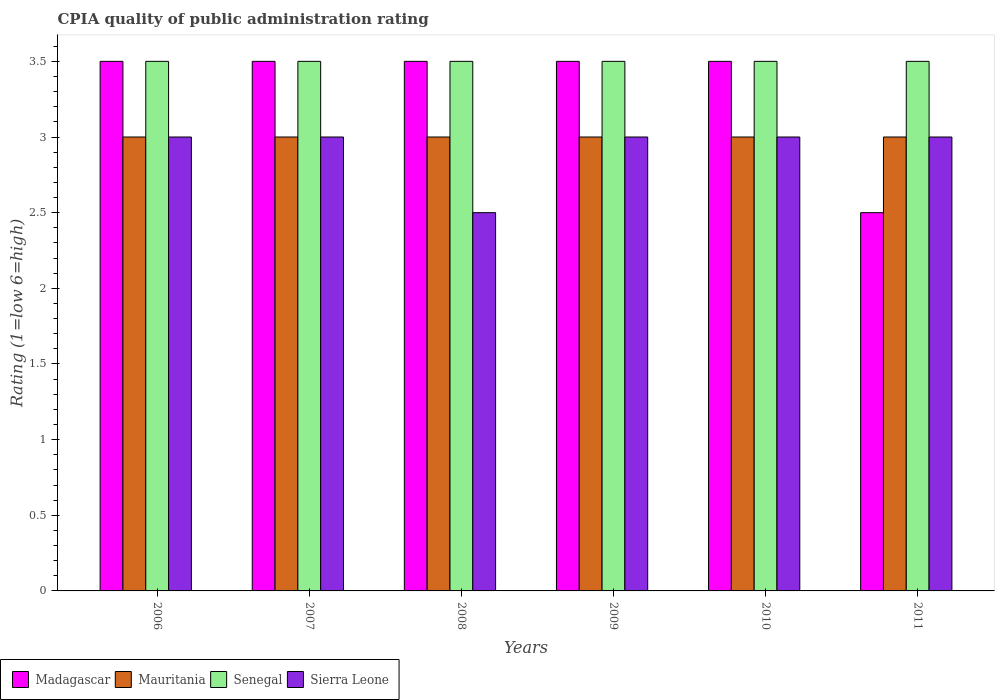How many different coloured bars are there?
Your response must be concise. 4. Are the number of bars on each tick of the X-axis equal?
Provide a short and direct response. Yes. In how many cases, is the number of bars for a given year not equal to the number of legend labels?
Your response must be concise. 0. In which year was the CPIA rating in Senegal maximum?
Your response must be concise. 2006. What is the difference between the CPIA rating in Madagascar in 2007 and that in 2008?
Ensure brevity in your answer.  0. What is the average CPIA rating in Sierra Leone per year?
Ensure brevity in your answer.  2.92. In the year 2006, what is the difference between the CPIA rating in Madagascar and CPIA rating in Sierra Leone?
Provide a succinct answer. 0.5. What is the ratio of the CPIA rating in Mauritania in 2007 to that in 2011?
Your answer should be very brief. 1. Is the CPIA rating in Sierra Leone in 2010 less than that in 2011?
Your response must be concise. No. Is the difference between the CPIA rating in Madagascar in 2010 and 2011 greater than the difference between the CPIA rating in Sierra Leone in 2010 and 2011?
Provide a short and direct response. Yes. What is the difference between the highest and the second highest CPIA rating in Madagascar?
Provide a succinct answer. 0. What is the difference between the highest and the lowest CPIA rating in Senegal?
Your answer should be compact. 0. Is it the case that in every year, the sum of the CPIA rating in Sierra Leone and CPIA rating in Mauritania is greater than the sum of CPIA rating in Madagascar and CPIA rating in Senegal?
Ensure brevity in your answer.  No. What does the 4th bar from the left in 2009 represents?
Provide a short and direct response. Sierra Leone. What does the 4th bar from the right in 2006 represents?
Offer a very short reply. Madagascar. How many years are there in the graph?
Keep it short and to the point. 6. Are the values on the major ticks of Y-axis written in scientific E-notation?
Offer a very short reply. No. Where does the legend appear in the graph?
Provide a succinct answer. Bottom left. How many legend labels are there?
Your answer should be compact. 4. What is the title of the graph?
Offer a very short reply. CPIA quality of public administration rating. Does "Europe(developing only)" appear as one of the legend labels in the graph?
Make the answer very short. No. What is the label or title of the X-axis?
Your response must be concise. Years. What is the Rating (1=low 6=high) in Mauritania in 2006?
Your answer should be very brief. 3. What is the Rating (1=low 6=high) in Senegal in 2006?
Your answer should be very brief. 3.5. What is the Rating (1=low 6=high) in Madagascar in 2007?
Ensure brevity in your answer.  3.5. What is the Rating (1=low 6=high) of Mauritania in 2007?
Your response must be concise. 3. What is the Rating (1=low 6=high) in Senegal in 2007?
Provide a succinct answer. 3.5. What is the Rating (1=low 6=high) in Sierra Leone in 2007?
Offer a very short reply. 3. What is the Rating (1=low 6=high) in Madagascar in 2008?
Your answer should be compact. 3.5. What is the Rating (1=low 6=high) in Sierra Leone in 2008?
Your answer should be very brief. 2.5. What is the Rating (1=low 6=high) of Madagascar in 2009?
Your answer should be very brief. 3.5. What is the Rating (1=low 6=high) of Senegal in 2009?
Keep it short and to the point. 3.5. What is the Rating (1=low 6=high) of Madagascar in 2010?
Provide a succinct answer. 3.5. What is the Rating (1=low 6=high) of Senegal in 2010?
Your answer should be compact. 3.5. What is the Rating (1=low 6=high) in Sierra Leone in 2010?
Provide a succinct answer. 3. What is the Rating (1=low 6=high) in Madagascar in 2011?
Give a very brief answer. 2.5. What is the Rating (1=low 6=high) in Senegal in 2011?
Your response must be concise. 3.5. Across all years, what is the maximum Rating (1=low 6=high) of Madagascar?
Offer a very short reply. 3.5. Across all years, what is the maximum Rating (1=low 6=high) in Mauritania?
Give a very brief answer. 3. Across all years, what is the minimum Rating (1=low 6=high) in Madagascar?
Offer a terse response. 2.5. Across all years, what is the minimum Rating (1=low 6=high) of Sierra Leone?
Offer a terse response. 2.5. What is the total Rating (1=low 6=high) in Madagascar in the graph?
Offer a terse response. 20. What is the total Rating (1=low 6=high) in Mauritania in the graph?
Offer a terse response. 18. What is the total Rating (1=low 6=high) in Senegal in the graph?
Provide a short and direct response. 21. What is the difference between the Rating (1=low 6=high) in Madagascar in 2006 and that in 2007?
Your response must be concise. 0. What is the difference between the Rating (1=low 6=high) in Mauritania in 2006 and that in 2007?
Offer a very short reply. 0. What is the difference between the Rating (1=low 6=high) in Senegal in 2006 and that in 2007?
Ensure brevity in your answer.  0. What is the difference between the Rating (1=low 6=high) in Mauritania in 2006 and that in 2008?
Offer a very short reply. 0. What is the difference between the Rating (1=low 6=high) of Mauritania in 2006 and that in 2009?
Your response must be concise. 0. What is the difference between the Rating (1=low 6=high) of Senegal in 2006 and that in 2009?
Provide a short and direct response. 0. What is the difference between the Rating (1=low 6=high) of Sierra Leone in 2006 and that in 2009?
Offer a terse response. 0. What is the difference between the Rating (1=low 6=high) in Madagascar in 2006 and that in 2010?
Offer a terse response. 0. What is the difference between the Rating (1=low 6=high) in Senegal in 2006 and that in 2010?
Offer a terse response. 0. What is the difference between the Rating (1=low 6=high) of Madagascar in 2006 and that in 2011?
Offer a terse response. 1. What is the difference between the Rating (1=low 6=high) in Mauritania in 2006 and that in 2011?
Provide a succinct answer. 0. What is the difference between the Rating (1=low 6=high) of Senegal in 2006 and that in 2011?
Provide a short and direct response. 0. What is the difference between the Rating (1=low 6=high) in Madagascar in 2007 and that in 2009?
Offer a very short reply. 0. What is the difference between the Rating (1=low 6=high) of Sierra Leone in 2007 and that in 2009?
Provide a short and direct response. 0. What is the difference between the Rating (1=low 6=high) in Madagascar in 2007 and that in 2011?
Give a very brief answer. 1. What is the difference between the Rating (1=low 6=high) in Mauritania in 2007 and that in 2011?
Your answer should be compact. 0. What is the difference between the Rating (1=low 6=high) in Sierra Leone in 2008 and that in 2009?
Make the answer very short. -0.5. What is the difference between the Rating (1=low 6=high) of Mauritania in 2008 and that in 2011?
Make the answer very short. 0. What is the difference between the Rating (1=low 6=high) in Madagascar in 2009 and that in 2010?
Give a very brief answer. 0. What is the difference between the Rating (1=low 6=high) of Senegal in 2009 and that in 2010?
Your answer should be compact. 0. What is the difference between the Rating (1=low 6=high) in Madagascar in 2009 and that in 2011?
Provide a short and direct response. 1. What is the difference between the Rating (1=low 6=high) in Mauritania in 2009 and that in 2011?
Your answer should be very brief. 0. What is the difference between the Rating (1=low 6=high) of Senegal in 2009 and that in 2011?
Provide a short and direct response. 0. What is the difference between the Rating (1=low 6=high) in Sierra Leone in 2009 and that in 2011?
Offer a very short reply. 0. What is the difference between the Rating (1=low 6=high) in Madagascar in 2010 and that in 2011?
Offer a very short reply. 1. What is the difference between the Rating (1=low 6=high) of Senegal in 2010 and that in 2011?
Your answer should be compact. 0. What is the difference between the Rating (1=low 6=high) in Mauritania in 2006 and the Rating (1=low 6=high) in Senegal in 2007?
Provide a short and direct response. -0.5. What is the difference between the Rating (1=low 6=high) in Mauritania in 2006 and the Rating (1=low 6=high) in Sierra Leone in 2007?
Keep it short and to the point. 0. What is the difference between the Rating (1=low 6=high) of Senegal in 2006 and the Rating (1=low 6=high) of Sierra Leone in 2007?
Your answer should be compact. 0.5. What is the difference between the Rating (1=low 6=high) in Madagascar in 2006 and the Rating (1=low 6=high) in Mauritania in 2008?
Your answer should be compact. 0.5. What is the difference between the Rating (1=low 6=high) of Madagascar in 2006 and the Rating (1=low 6=high) of Senegal in 2008?
Your answer should be compact. 0. What is the difference between the Rating (1=low 6=high) of Mauritania in 2006 and the Rating (1=low 6=high) of Sierra Leone in 2008?
Make the answer very short. 0.5. What is the difference between the Rating (1=low 6=high) in Madagascar in 2006 and the Rating (1=low 6=high) in Mauritania in 2009?
Provide a succinct answer. 0.5. What is the difference between the Rating (1=low 6=high) in Madagascar in 2006 and the Rating (1=low 6=high) in Senegal in 2009?
Keep it short and to the point. 0. What is the difference between the Rating (1=low 6=high) in Madagascar in 2006 and the Rating (1=low 6=high) in Sierra Leone in 2009?
Keep it short and to the point. 0.5. What is the difference between the Rating (1=low 6=high) in Mauritania in 2006 and the Rating (1=low 6=high) in Senegal in 2009?
Ensure brevity in your answer.  -0.5. What is the difference between the Rating (1=low 6=high) in Mauritania in 2006 and the Rating (1=low 6=high) in Sierra Leone in 2009?
Provide a succinct answer. 0. What is the difference between the Rating (1=low 6=high) of Madagascar in 2006 and the Rating (1=low 6=high) of Mauritania in 2010?
Offer a very short reply. 0.5. What is the difference between the Rating (1=low 6=high) in Madagascar in 2006 and the Rating (1=low 6=high) in Sierra Leone in 2010?
Keep it short and to the point. 0.5. What is the difference between the Rating (1=low 6=high) of Mauritania in 2006 and the Rating (1=low 6=high) of Senegal in 2010?
Your answer should be very brief. -0.5. What is the difference between the Rating (1=low 6=high) in Senegal in 2006 and the Rating (1=low 6=high) in Sierra Leone in 2010?
Your answer should be compact. 0.5. What is the difference between the Rating (1=low 6=high) of Madagascar in 2006 and the Rating (1=low 6=high) of Mauritania in 2011?
Your answer should be very brief. 0.5. What is the difference between the Rating (1=low 6=high) in Mauritania in 2006 and the Rating (1=low 6=high) in Senegal in 2011?
Make the answer very short. -0.5. What is the difference between the Rating (1=low 6=high) in Senegal in 2006 and the Rating (1=low 6=high) in Sierra Leone in 2011?
Ensure brevity in your answer.  0.5. What is the difference between the Rating (1=low 6=high) in Madagascar in 2007 and the Rating (1=low 6=high) in Mauritania in 2008?
Provide a short and direct response. 0.5. What is the difference between the Rating (1=low 6=high) of Madagascar in 2007 and the Rating (1=low 6=high) of Senegal in 2008?
Offer a very short reply. 0. What is the difference between the Rating (1=low 6=high) of Madagascar in 2007 and the Rating (1=low 6=high) of Sierra Leone in 2008?
Provide a succinct answer. 1. What is the difference between the Rating (1=low 6=high) of Mauritania in 2007 and the Rating (1=low 6=high) of Senegal in 2008?
Your answer should be compact. -0.5. What is the difference between the Rating (1=low 6=high) of Mauritania in 2007 and the Rating (1=low 6=high) of Sierra Leone in 2008?
Provide a succinct answer. 0.5. What is the difference between the Rating (1=low 6=high) in Senegal in 2007 and the Rating (1=low 6=high) in Sierra Leone in 2008?
Your answer should be very brief. 1. What is the difference between the Rating (1=low 6=high) of Madagascar in 2007 and the Rating (1=low 6=high) of Senegal in 2009?
Provide a short and direct response. 0. What is the difference between the Rating (1=low 6=high) of Mauritania in 2007 and the Rating (1=low 6=high) of Senegal in 2009?
Make the answer very short. -0.5. What is the difference between the Rating (1=low 6=high) of Madagascar in 2007 and the Rating (1=low 6=high) of Senegal in 2010?
Provide a succinct answer. 0. What is the difference between the Rating (1=low 6=high) in Mauritania in 2007 and the Rating (1=low 6=high) in Senegal in 2010?
Provide a short and direct response. -0.5. What is the difference between the Rating (1=low 6=high) in Madagascar in 2007 and the Rating (1=low 6=high) in Mauritania in 2011?
Your answer should be compact. 0.5. What is the difference between the Rating (1=low 6=high) of Madagascar in 2007 and the Rating (1=low 6=high) of Sierra Leone in 2011?
Make the answer very short. 0.5. What is the difference between the Rating (1=low 6=high) in Mauritania in 2007 and the Rating (1=low 6=high) in Senegal in 2011?
Provide a succinct answer. -0.5. What is the difference between the Rating (1=low 6=high) of Mauritania in 2007 and the Rating (1=low 6=high) of Sierra Leone in 2011?
Ensure brevity in your answer.  0. What is the difference between the Rating (1=low 6=high) in Madagascar in 2008 and the Rating (1=low 6=high) in Senegal in 2009?
Your response must be concise. 0. What is the difference between the Rating (1=low 6=high) in Madagascar in 2008 and the Rating (1=low 6=high) in Sierra Leone in 2009?
Make the answer very short. 0.5. What is the difference between the Rating (1=low 6=high) of Senegal in 2008 and the Rating (1=low 6=high) of Sierra Leone in 2009?
Make the answer very short. 0.5. What is the difference between the Rating (1=low 6=high) of Madagascar in 2008 and the Rating (1=low 6=high) of Senegal in 2010?
Your answer should be very brief. 0. What is the difference between the Rating (1=low 6=high) in Mauritania in 2008 and the Rating (1=low 6=high) in Senegal in 2010?
Ensure brevity in your answer.  -0.5. What is the difference between the Rating (1=low 6=high) of Mauritania in 2008 and the Rating (1=low 6=high) of Sierra Leone in 2010?
Give a very brief answer. 0. What is the difference between the Rating (1=low 6=high) in Madagascar in 2008 and the Rating (1=low 6=high) in Mauritania in 2011?
Offer a terse response. 0.5. What is the difference between the Rating (1=low 6=high) of Madagascar in 2008 and the Rating (1=low 6=high) of Senegal in 2011?
Provide a succinct answer. 0. What is the difference between the Rating (1=low 6=high) of Madagascar in 2008 and the Rating (1=low 6=high) of Sierra Leone in 2011?
Keep it short and to the point. 0.5. What is the difference between the Rating (1=low 6=high) in Mauritania in 2008 and the Rating (1=low 6=high) in Sierra Leone in 2011?
Offer a very short reply. 0. What is the difference between the Rating (1=low 6=high) in Senegal in 2008 and the Rating (1=low 6=high) in Sierra Leone in 2011?
Your answer should be very brief. 0.5. What is the difference between the Rating (1=low 6=high) of Mauritania in 2009 and the Rating (1=low 6=high) of Senegal in 2010?
Your answer should be compact. -0.5. What is the difference between the Rating (1=low 6=high) of Senegal in 2009 and the Rating (1=low 6=high) of Sierra Leone in 2010?
Make the answer very short. 0.5. What is the difference between the Rating (1=low 6=high) in Madagascar in 2009 and the Rating (1=low 6=high) in Mauritania in 2011?
Give a very brief answer. 0.5. What is the difference between the Rating (1=low 6=high) in Madagascar in 2009 and the Rating (1=low 6=high) in Sierra Leone in 2011?
Your answer should be very brief. 0.5. What is the difference between the Rating (1=low 6=high) in Mauritania in 2009 and the Rating (1=low 6=high) in Senegal in 2011?
Provide a short and direct response. -0.5. What is the difference between the Rating (1=low 6=high) of Mauritania in 2009 and the Rating (1=low 6=high) of Sierra Leone in 2011?
Your answer should be compact. 0. What is the difference between the Rating (1=low 6=high) in Senegal in 2009 and the Rating (1=low 6=high) in Sierra Leone in 2011?
Offer a very short reply. 0.5. What is the difference between the Rating (1=low 6=high) of Madagascar in 2010 and the Rating (1=low 6=high) of Senegal in 2011?
Offer a very short reply. 0. What is the difference between the Rating (1=low 6=high) of Madagascar in 2010 and the Rating (1=low 6=high) of Sierra Leone in 2011?
Make the answer very short. 0.5. What is the difference between the Rating (1=low 6=high) in Mauritania in 2010 and the Rating (1=low 6=high) in Senegal in 2011?
Make the answer very short. -0.5. What is the difference between the Rating (1=low 6=high) of Mauritania in 2010 and the Rating (1=low 6=high) of Sierra Leone in 2011?
Provide a short and direct response. 0. What is the average Rating (1=low 6=high) in Senegal per year?
Give a very brief answer. 3.5. What is the average Rating (1=low 6=high) of Sierra Leone per year?
Keep it short and to the point. 2.92. In the year 2006, what is the difference between the Rating (1=low 6=high) of Madagascar and Rating (1=low 6=high) of Mauritania?
Give a very brief answer. 0.5. In the year 2006, what is the difference between the Rating (1=low 6=high) of Madagascar and Rating (1=low 6=high) of Senegal?
Your answer should be compact. 0. In the year 2006, what is the difference between the Rating (1=low 6=high) in Mauritania and Rating (1=low 6=high) in Senegal?
Provide a succinct answer. -0.5. In the year 2006, what is the difference between the Rating (1=low 6=high) in Mauritania and Rating (1=low 6=high) in Sierra Leone?
Your answer should be very brief. 0. In the year 2007, what is the difference between the Rating (1=low 6=high) of Madagascar and Rating (1=low 6=high) of Mauritania?
Ensure brevity in your answer.  0.5. In the year 2007, what is the difference between the Rating (1=low 6=high) of Madagascar and Rating (1=low 6=high) of Senegal?
Your response must be concise. 0. In the year 2007, what is the difference between the Rating (1=low 6=high) of Madagascar and Rating (1=low 6=high) of Sierra Leone?
Make the answer very short. 0.5. In the year 2007, what is the difference between the Rating (1=low 6=high) in Mauritania and Rating (1=low 6=high) in Senegal?
Provide a succinct answer. -0.5. In the year 2007, what is the difference between the Rating (1=low 6=high) of Mauritania and Rating (1=low 6=high) of Sierra Leone?
Make the answer very short. 0. In the year 2007, what is the difference between the Rating (1=low 6=high) of Senegal and Rating (1=low 6=high) of Sierra Leone?
Your answer should be compact. 0.5. In the year 2008, what is the difference between the Rating (1=low 6=high) in Madagascar and Rating (1=low 6=high) in Senegal?
Provide a succinct answer. 0. In the year 2008, what is the difference between the Rating (1=low 6=high) in Madagascar and Rating (1=low 6=high) in Sierra Leone?
Your response must be concise. 1. In the year 2009, what is the difference between the Rating (1=low 6=high) in Madagascar and Rating (1=low 6=high) in Mauritania?
Your response must be concise. 0.5. In the year 2009, what is the difference between the Rating (1=low 6=high) in Madagascar and Rating (1=low 6=high) in Senegal?
Your answer should be compact. 0. In the year 2009, what is the difference between the Rating (1=low 6=high) in Mauritania and Rating (1=low 6=high) in Senegal?
Make the answer very short. -0.5. In the year 2009, what is the difference between the Rating (1=low 6=high) in Senegal and Rating (1=low 6=high) in Sierra Leone?
Your response must be concise. 0.5. In the year 2010, what is the difference between the Rating (1=low 6=high) in Madagascar and Rating (1=low 6=high) in Senegal?
Keep it short and to the point. 0. In the year 2010, what is the difference between the Rating (1=low 6=high) in Madagascar and Rating (1=low 6=high) in Sierra Leone?
Offer a terse response. 0.5. In the year 2010, what is the difference between the Rating (1=low 6=high) of Mauritania and Rating (1=low 6=high) of Senegal?
Offer a very short reply. -0.5. In the year 2010, what is the difference between the Rating (1=low 6=high) in Senegal and Rating (1=low 6=high) in Sierra Leone?
Offer a terse response. 0.5. In the year 2011, what is the difference between the Rating (1=low 6=high) in Madagascar and Rating (1=low 6=high) in Senegal?
Provide a succinct answer. -1. In the year 2011, what is the difference between the Rating (1=low 6=high) in Madagascar and Rating (1=low 6=high) in Sierra Leone?
Provide a succinct answer. -0.5. What is the ratio of the Rating (1=low 6=high) of Madagascar in 2006 to that in 2007?
Provide a succinct answer. 1. What is the ratio of the Rating (1=low 6=high) in Sierra Leone in 2006 to that in 2007?
Provide a short and direct response. 1. What is the ratio of the Rating (1=low 6=high) in Madagascar in 2006 to that in 2008?
Your response must be concise. 1. What is the ratio of the Rating (1=low 6=high) in Sierra Leone in 2006 to that in 2008?
Offer a terse response. 1.2. What is the ratio of the Rating (1=low 6=high) in Senegal in 2006 to that in 2009?
Your response must be concise. 1. What is the ratio of the Rating (1=low 6=high) of Sierra Leone in 2006 to that in 2009?
Provide a short and direct response. 1. What is the ratio of the Rating (1=low 6=high) in Senegal in 2006 to that in 2010?
Your answer should be compact. 1. What is the ratio of the Rating (1=low 6=high) in Madagascar in 2006 to that in 2011?
Provide a succinct answer. 1.4. What is the ratio of the Rating (1=low 6=high) of Mauritania in 2006 to that in 2011?
Give a very brief answer. 1. What is the ratio of the Rating (1=low 6=high) in Senegal in 2006 to that in 2011?
Make the answer very short. 1. What is the ratio of the Rating (1=low 6=high) of Sierra Leone in 2006 to that in 2011?
Keep it short and to the point. 1. What is the ratio of the Rating (1=low 6=high) in Madagascar in 2007 to that in 2008?
Offer a terse response. 1. What is the ratio of the Rating (1=low 6=high) in Mauritania in 2007 to that in 2008?
Your answer should be compact. 1. What is the ratio of the Rating (1=low 6=high) in Sierra Leone in 2007 to that in 2008?
Make the answer very short. 1.2. What is the ratio of the Rating (1=low 6=high) of Madagascar in 2007 to that in 2009?
Keep it short and to the point. 1. What is the ratio of the Rating (1=low 6=high) in Senegal in 2007 to that in 2009?
Your answer should be very brief. 1. What is the ratio of the Rating (1=low 6=high) of Sierra Leone in 2007 to that in 2009?
Ensure brevity in your answer.  1. What is the ratio of the Rating (1=low 6=high) in Madagascar in 2007 to that in 2010?
Provide a succinct answer. 1. What is the ratio of the Rating (1=low 6=high) of Mauritania in 2007 to that in 2010?
Make the answer very short. 1. What is the ratio of the Rating (1=low 6=high) of Sierra Leone in 2007 to that in 2010?
Ensure brevity in your answer.  1. What is the ratio of the Rating (1=low 6=high) of Mauritania in 2007 to that in 2011?
Offer a very short reply. 1. What is the ratio of the Rating (1=low 6=high) of Senegal in 2007 to that in 2011?
Make the answer very short. 1. What is the ratio of the Rating (1=low 6=high) in Sierra Leone in 2007 to that in 2011?
Make the answer very short. 1. What is the ratio of the Rating (1=low 6=high) of Sierra Leone in 2008 to that in 2009?
Your answer should be very brief. 0.83. What is the ratio of the Rating (1=low 6=high) in Madagascar in 2008 to that in 2011?
Your answer should be compact. 1.4. What is the ratio of the Rating (1=low 6=high) in Senegal in 2008 to that in 2011?
Your response must be concise. 1. What is the ratio of the Rating (1=low 6=high) in Sierra Leone in 2008 to that in 2011?
Offer a terse response. 0.83. What is the ratio of the Rating (1=low 6=high) of Mauritania in 2009 to that in 2010?
Provide a succinct answer. 1. What is the ratio of the Rating (1=low 6=high) of Madagascar in 2009 to that in 2011?
Your response must be concise. 1.4. What is the ratio of the Rating (1=low 6=high) in Mauritania in 2009 to that in 2011?
Provide a short and direct response. 1. What is the ratio of the Rating (1=low 6=high) of Madagascar in 2010 to that in 2011?
Offer a very short reply. 1.4. What is the ratio of the Rating (1=low 6=high) of Senegal in 2010 to that in 2011?
Provide a succinct answer. 1. What is the ratio of the Rating (1=low 6=high) in Sierra Leone in 2010 to that in 2011?
Your response must be concise. 1. What is the difference between the highest and the second highest Rating (1=low 6=high) in Senegal?
Provide a succinct answer. 0. What is the difference between the highest and the lowest Rating (1=low 6=high) of Madagascar?
Provide a succinct answer. 1. What is the difference between the highest and the lowest Rating (1=low 6=high) in Mauritania?
Offer a terse response. 0. 